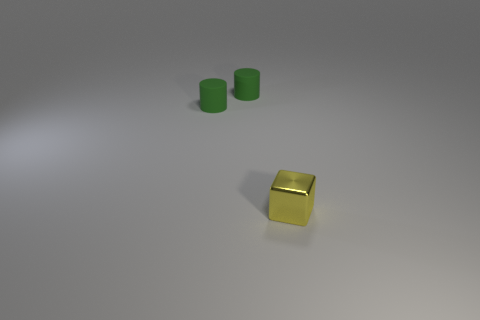What is the yellow thing made of?
Make the answer very short. Metal. How many objects are small green cylinders or shiny things?
Make the answer very short. 3. What number of other objects are there of the same size as the yellow metallic cube?
Give a very brief answer. 2. What number of other objects are there of the same shape as the tiny yellow object?
Give a very brief answer. 0. Are there the same number of yellow cubes left of the small metal block and tiny green matte cylinders?
Make the answer very short. No. Are there any other things that have the same material as the yellow thing?
Keep it short and to the point. No. Are there fewer tiny green cylinders that are right of the block than yellow shiny cubes?
Keep it short and to the point. Yes. What number of things have the same color as the shiny cube?
Provide a succinct answer. 0. Is there a matte cylinder of the same size as the metal cube?
Ensure brevity in your answer.  Yes. Is there another small object of the same shape as the yellow shiny object?
Your answer should be very brief. No. 